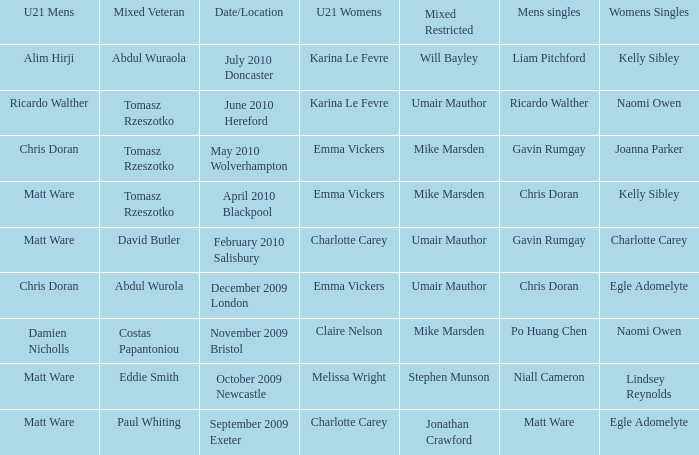When Matt Ware won the mens singles, who won the mixed restricted? Jonathan Crawford. 